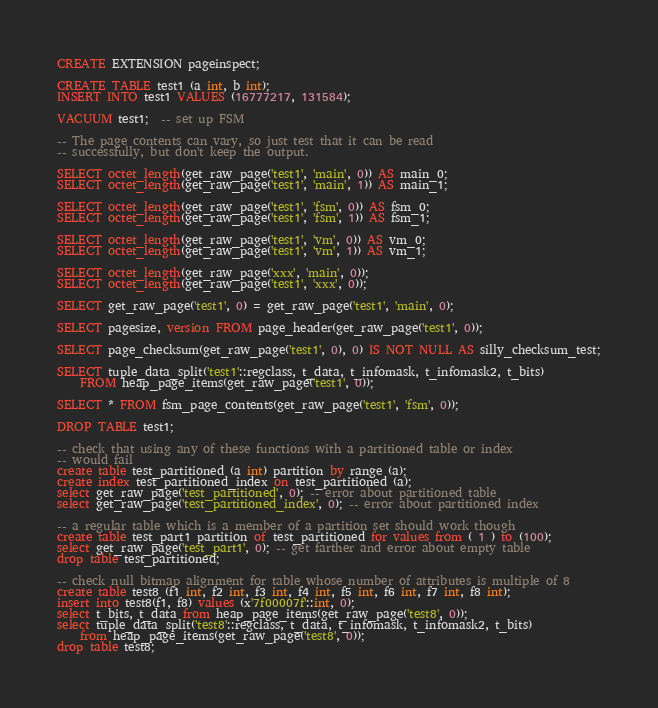Convert code to text. <code><loc_0><loc_0><loc_500><loc_500><_SQL_>CREATE EXTENSION pageinspect;

CREATE TABLE test1 (a int, b int);
INSERT INTO test1 VALUES (16777217, 131584);

VACUUM test1;  -- set up FSM

-- The page contents can vary, so just test that it can be read
-- successfully, but don't keep the output.

SELECT octet_length(get_raw_page('test1', 'main', 0)) AS main_0;
SELECT octet_length(get_raw_page('test1', 'main', 1)) AS main_1;

SELECT octet_length(get_raw_page('test1', 'fsm', 0)) AS fsm_0;
SELECT octet_length(get_raw_page('test1', 'fsm', 1)) AS fsm_1;

SELECT octet_length(get_raw_page('test1', 'vm', 0)) AS vm_0;
SELECT octet_length(get_raw_page('test1', 'vm', 1)) AS vm_1;

SELECT octet_length(get_raw_page('xxx', 'main', 0));
SELECT octet_length(get_raw_page('test1', 'xxx', 0));

SELECT get_raw_page('test1', 0) = get_raw_page('test1', 'main', 0);

SELECT pagesize, version FROM page_header(get_raw_page('test1', 0));

SELECT page_checksum(get_raw_page('test1', 0), 0) IS NOT NULL AS silly_checksum_test;

SELECT tuple_data_split('test1'::regclass, t_data, t_infomask, t_infomask2, t_bits)
    FROM heap_page_items(get_raw_page('test1', 0));

SELECT * FROM fsm_page_contents(get_raw_page('test1', 'fsm', 0));

DROP TABLE test1;

-- check that using any of these functions with a partitioned table or index
-- would fail
create table test_partitioned (a int) partition by range (a);
create index test_partitioned_index on test_partitioned (a);
select get_raw_page('test_partitioned', 0); -- error about partitioned table
select get_raw_page('test_partitioned_index', 0); -- error about partitioned index

-- a regular table which is a member of a partition set should work though
create table test_part1 partition of test_partitioned for values from ( 1 ) to (100);
select get_raw_page('test_part1', 0); -- get farther and error about empty table
drop table test_partitioned;

-- check null bitmap alignment for table whose number of attributes is multiple of 8
create table test8 (f1 int, f2 int, f3 int, f4 int, f5 int, f6 int, f7 int, f8 int);
insert into test8(f1, f8) values (x'7f00007f'::int, 0);
select t_bits, t_data from heap_page_items(get_raw_page('test8', 0));
select tuple_data_split('test8'::regclass, t_data, t_infomask, t_infomask2, t_bits)
    from heap_page_items(get_raw_page('test8', 0));
drop table test8;
</code> 